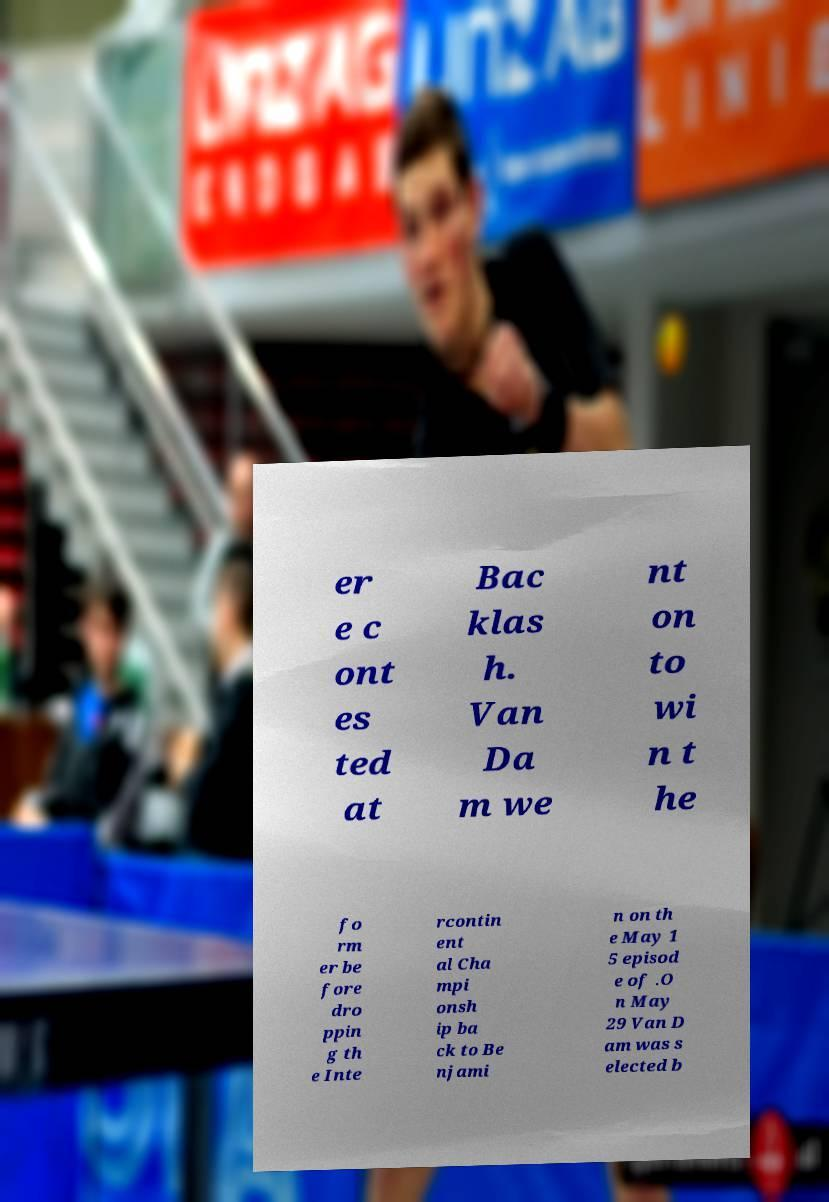Please identify and transcribe the text found in this image. er e c ont es ted at Bac klas h. Van Da m we nt on to wi n t he fo rm er be fore dro ppin g th e Inte rcontin ent al Cha mpi onsh ip ba ck to Be njami n on th e May 1 5 episod e of .O n May 29 Van D am was s elected b 